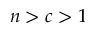<formula> <loc_0><loc_0><loc_500><loc_500>n > c > 1</formula> 